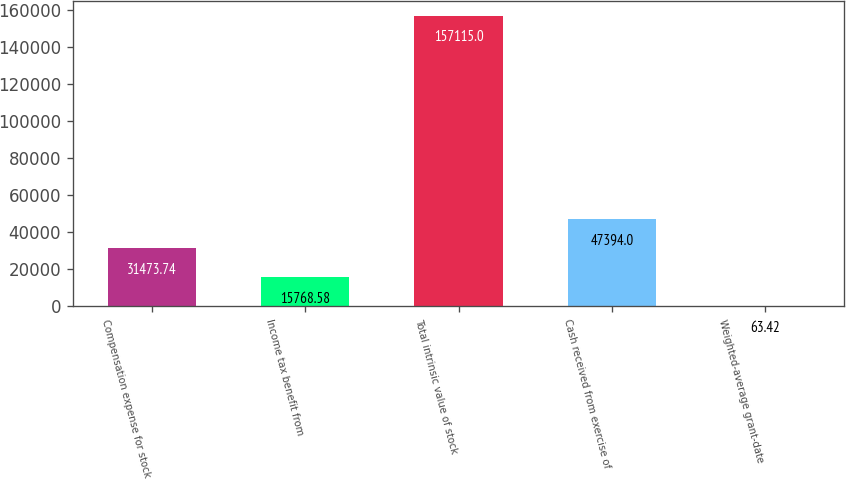<chart> <loc_0><loc_0><loc_500><loc_500><bar_chart><fcel>Compensation expense for stock<fcel>Income tax benefit from<fcel>Total intrinsic value of stock<fcel>Cash received from exercise of<fcel>Weighted-average grant-date<nl><fcel>31473.7<fcel>15768.6<fcel>157115<fcel>47394<fcel>63.42<nl></chart> 